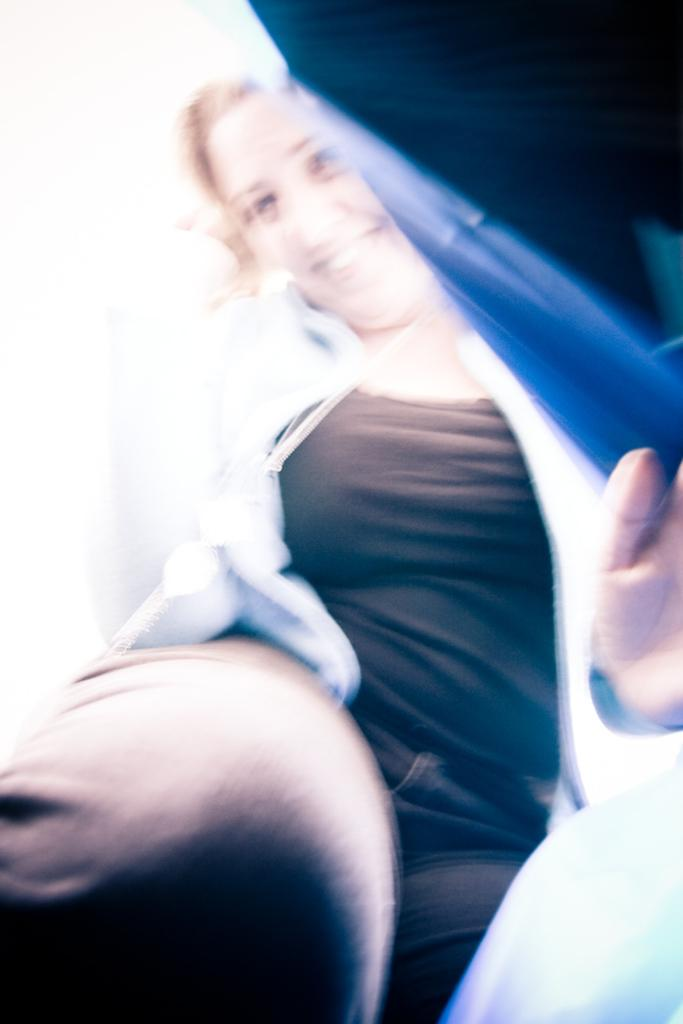Who is present in the image? There is a woman in the image. What is the woman doing in the image? The woman is standing and removing a blue cover. What is the woman wearing in the image? The woman is wearing a black T-shirt and a white shirt. How is the woman feeling in the image? The woman is smiling in the image. What type of kite is the woman holding in the image? There is no kite present in the image; the woman is removing a blue cover. 